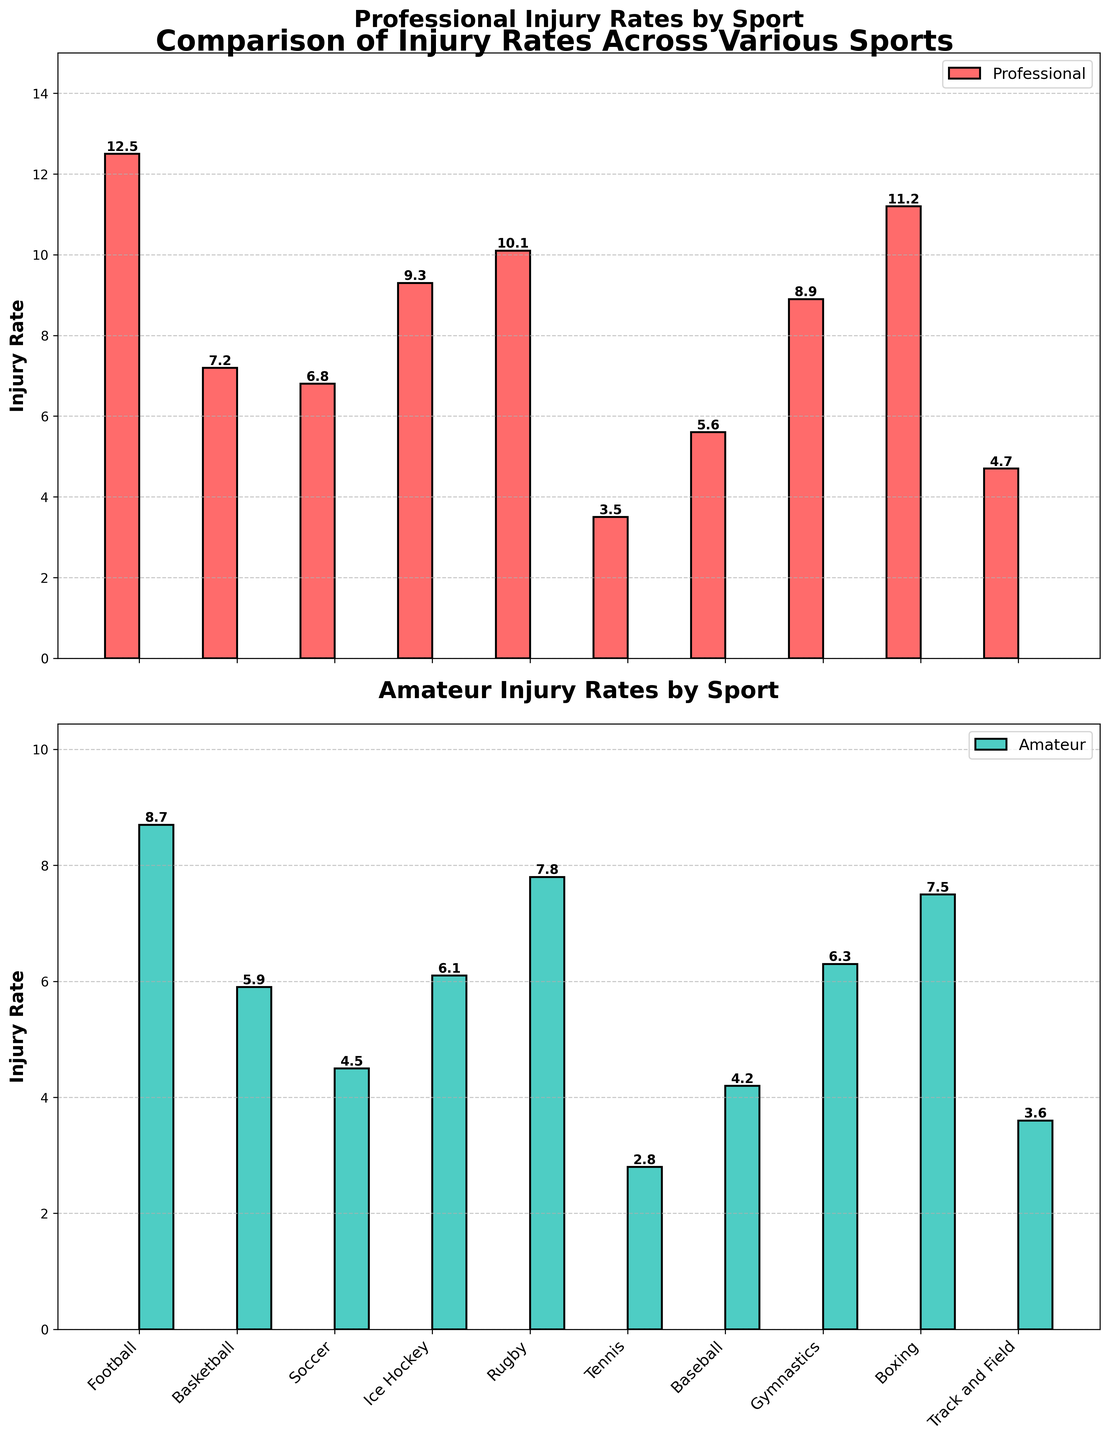What sport has the highest professional injury rate? The highest bar in the top subplot represents the sport with the highest professional injury rate. In this case, it is Football with an injury rate of 12.5.
Answer: Football What are the professional and amateur injury rates for Boxing? Locate the corresponding bars for Boxing in both subplots. The height of the bars indicates the injury rates which are 11.2 for professional and 7.5 for amateur.
Answer: Professional: 11.2, Amateur: 7.5 Which sport has the smallest difference between professional and amateur injury rates? Calculate the difference for each sport by subtracting the amateur rate from the professional rate. Tennis shows the smallest difference (3.5 - 2.8 = 0.7).
Answer: Tennis How do the professional injury rates for Ice Hockey and Rugby compare? Compare the heights of the bars representing Ice Hockey and Rugby in the top subplot. Ice Hockey has a rate of 9.3, whereas Rugby has a rate of 10.1. Hence, Rugby has a higher professional injury rate.
Answer: Rugby > Ice Hockey What's the average injury rate for professionals across all sports? Sum up all the professional injury rates and divide by the number of sports. (12.5 + 7.2 + 6.8 + 9.3 + 10.1 + 3.5 + 5.6 + 8.9 + 11.2 + 4.7) / 10 = 8.28.
Answer: 8.28 Which sport's amateur injury rate is closest to the professional injury rate of Tennis? Identify the professional injury rate of Tennis (3.5) and find the amateur rate closest to this value from the bottom subplot. Track and Field’s amateur rate of 3.6 is closest to 3.5.
Answer: Track and Field Are there any sports where the amateur injury rate exceeds 7? Check the amateur injury rates in the bottom subplot. Amateur injury rates exceeding 7 include Rugby (7.8) and Boxing (7.5).
Answer: Rugby, Boxing What is the combined injury rate for Gymnastics at both levels? Sum the professional and amateur injury rates for Gymnastics. 8.9 (professional) + 6.3 (amateur) = 15.2.
Answer: 15.2 Which sport has the lowest amateur injury rate and what is the rate? Identify the shortest bar in the bottom subplot representing amateur rates. Tennis has the lowest rate of 2.8.
Answer: Tennis, 2.8 How do the professional and amateur injury rates vary for Soccer? Compare the bars for Soccer in both subplots. The professional injury rate for Soccer is 6.8, while the amateur injury rate is 4.5.
Answer: Professional: 6.8, Amateur: 4.5 